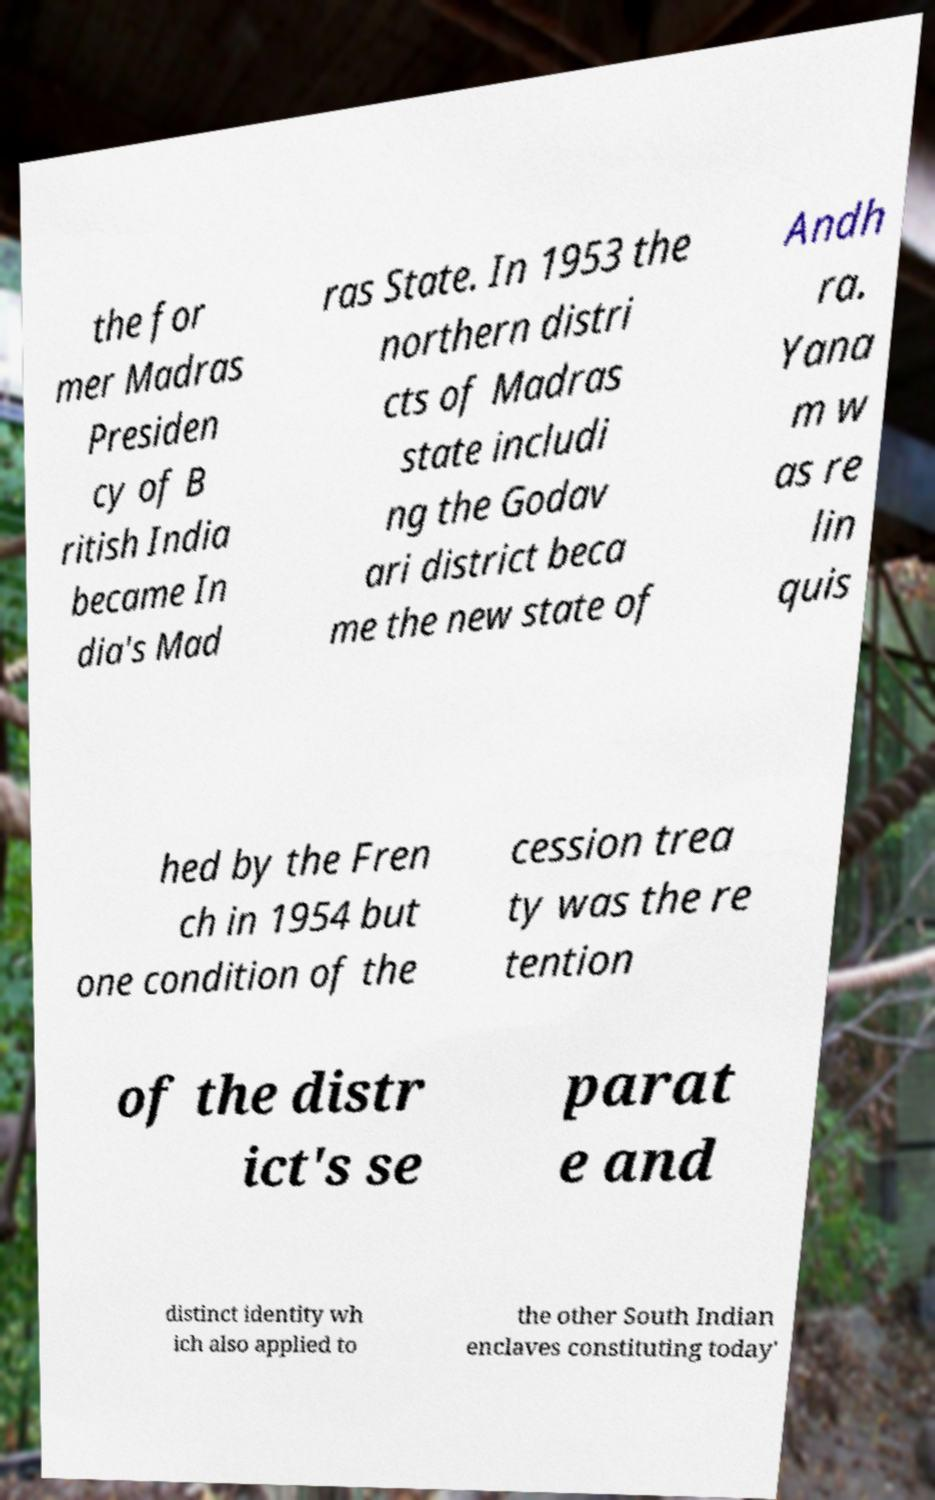Could you assist in decoding the text presented in this image and type it out clearly? the for mer Madras Presiden cy of B ritish India became In dia's Mad ras State. In 1953 the northern distri cts of Madras state includi ng the Godav ari district beca me the new state of Andh ra. Yana m w as re lin quis hed by the Fren ch in 1954 but one condition of the cession trea ty was the re tention of the distr ict's se parat e and distinct identity wh ich also applied to the other South Indian enclaves constituting today' 